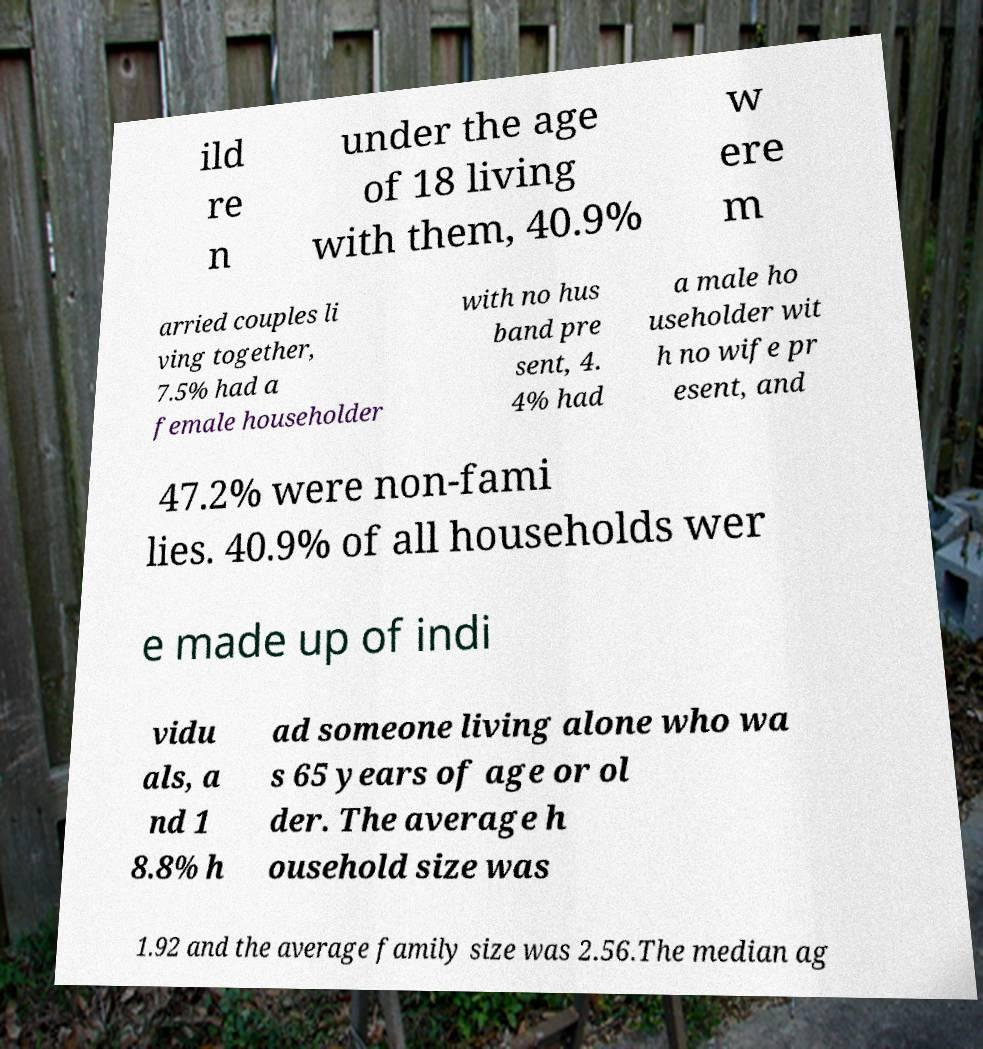Could you assist in decoding the text presented in this image and type it out clearly? ild re n under the age of 18 living with them, 40.9% w ere m arried couples li ving together, 7.5% had a female householder with no hus band pre sent, 4. 4% had a male ho useholder wit h no wife pr esent, and 47.2% were non-fami lies. 40.9% of all households wer e made up of indi vidu als, a nd 1 8.8% h ad someone living alone who wa s 65 years of age or ol der. The average h ousehold size was 1.92 and the average family size was 2.56.The median ag 